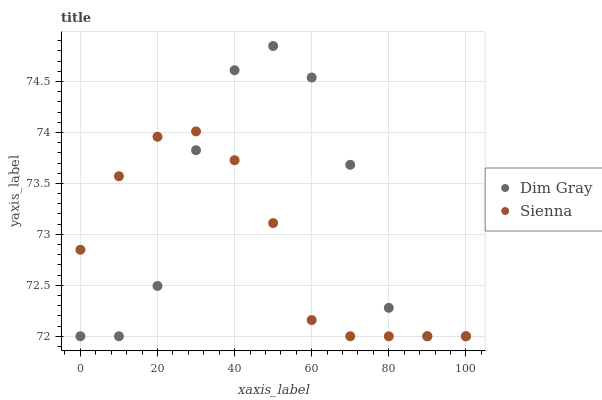Does Sienna have the minimum area under the curve?
Answer yes or no. Yes. Does Dim Gray have the maximum area under the curve?
Answer yes or no. Yes. Does Dim Gray have the minimum area under the curve?
Answer yes or no. No. Is Sienna the smoothest?
Answer yes or no. Yes. Is Dim Gray the roughest?
Answer yes or no. Yes. Is Dim Gray the smoothest?
Answer yes or no. No. Does Sienna have the lowest value?
Answer yes or no. Yes. Does Dim Gray have the highest value?
Answer yes or no. Yes. Does Sienna intersect Dim Gray?
Answer yes or no. Yes. Is Sienna less than Dim Gray?
Answer yes or no. No. Is Sienna greater than Dim Gray?
Answer yes or no. No. 